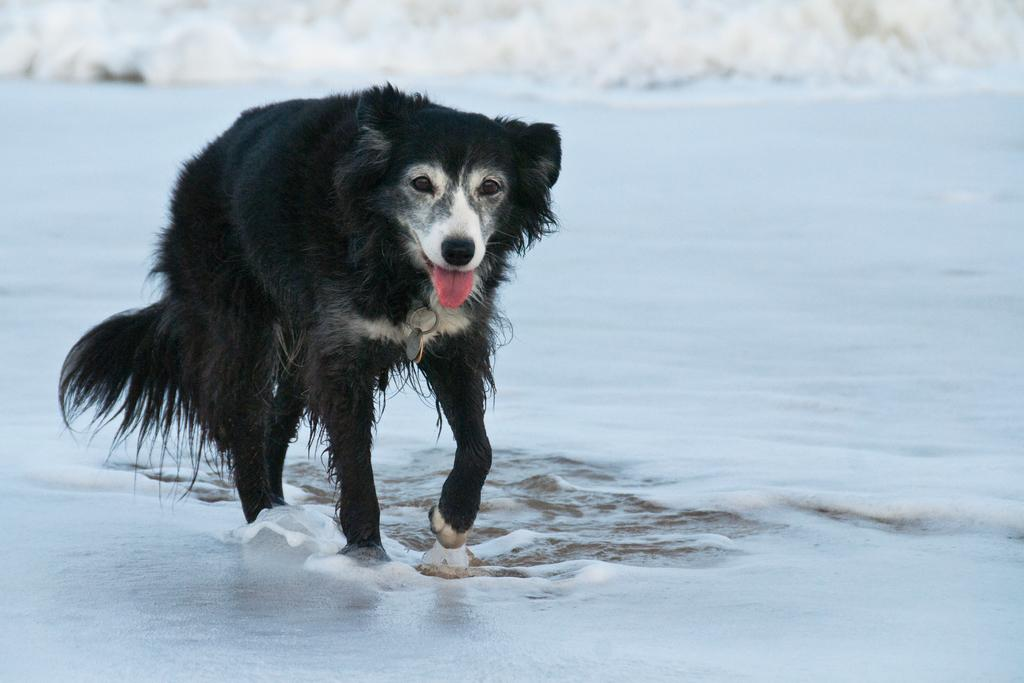What type of animal is in the image? There is a dog in the image. What is the dog doing in the image? The dog is walking in the image. What can be seen in the background of the image? There is water visible in the image. What is happening with the water in the image? There is a wave approaching at the top of the image. What type of crown is the dog wearing in the image? There is no crown present in the image; the dog is not wearing any accessories. 